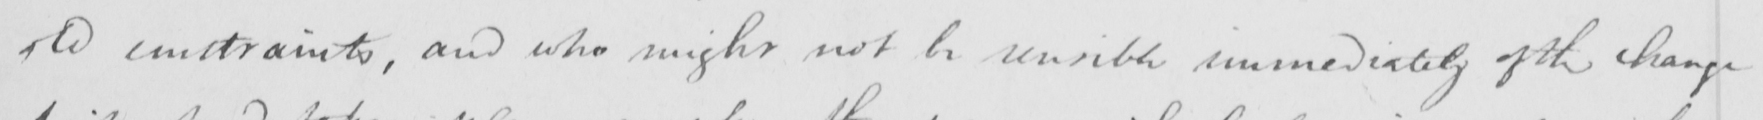Please transcribe the handwritten text in this image. old constraints , and who might not be sensible immediately of the change 